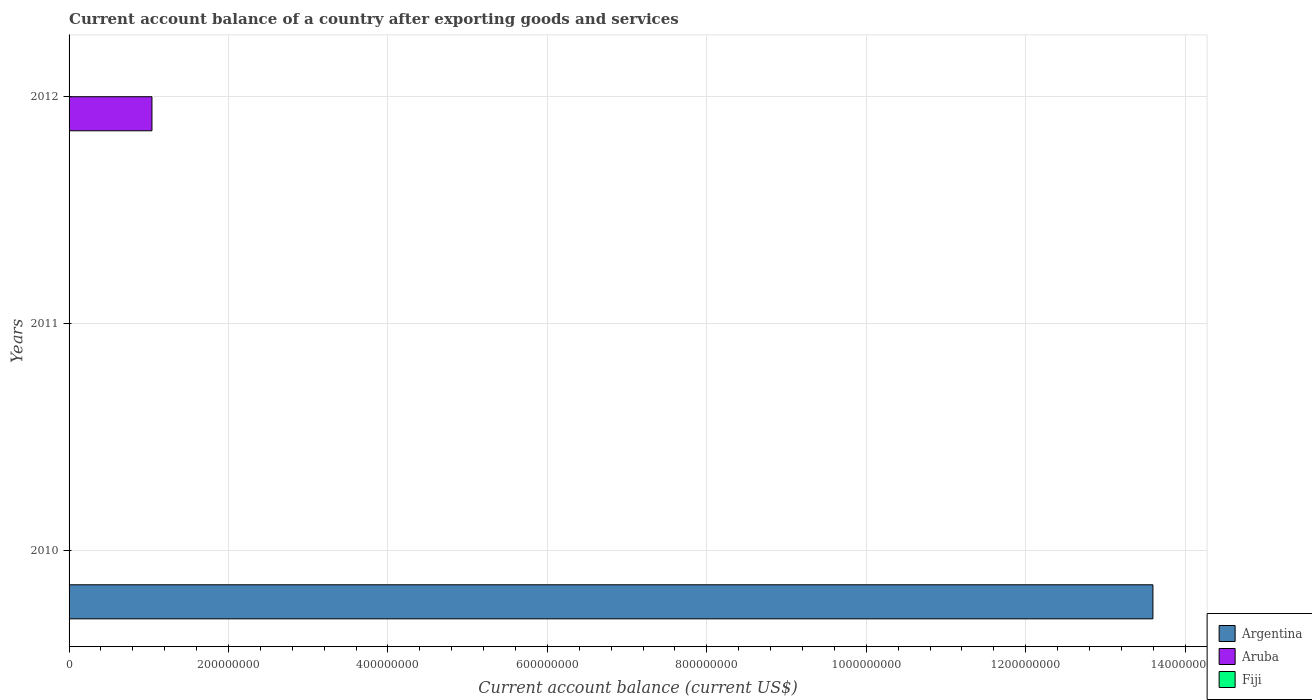How many bars are there on the 3rd tick from the bottom?
Your answer should be compact. 1. In how many cases, is the number of bars for a given year not equal to the number of legend labels?
Make the answer very short. 3. What is the account balance in Argentina in 2012?
Your answer should be very brief. 0. Across all years, what is the maximum account balance in Aruba?
Ensure brevity in your answer.  1.04e+08. Across all years, what is the minimum account balance in Aruba?
Provide a short and direct response. 0. In which year was the account balance in Aruba maximum?
Offer a very short reply. 2012. What is the total account balance in Argentina in the graph?
Provide a succinct answer. 1.36e+09. What is the average account balance in Aruba per year?
Give a very brief answer. 3.47e+07. In how many years, is the account balance in Fiji greater than 1280000000 US$?
Offer a terse response. 0. What is the difference between the highest and the lowest account balance in Argentina?
Ensure brevity in your answer.  1.36e+09. Is it the case that in every year, the sum of the account balance in Argentina and account balance in Fiji is greater than the account balance in Aruba?
Offer a terse response. No. How many years are there in the graph?
Make the answer very short. 3. What is the difference between two consecutive major ticks on the X-axis?
Offer a terse response. 2.00e+08. Does the graph contain any zero values?
Offer a terse response. Yes. Where does the legend appear in the graph?
Ensure brevity in your answer.  Bottom right. How many legend labels are there?
Make the answer very short. 3. What is the title of the graph?
Ensure brevity in your answer.  Current account balance of a country after exporting goods and services. Does "Greenland" appear as one of the legend labels in the graph?
Ensure brevity in your answer.  No. What is the label or title of the X-axis?
Offer a very short reply. Current account balance (current US$). What is the Current account balance (current US$) in Argentina in 2010?
Offer a very short reply. 1.36e+09. What is the Current account balance (current US$) in Fiji in 2010?
Provide a short and direct response. 0. What is the Current account balance (current US$) of Fiji in 2011?
Give a very brief answer. 0. What is the Current account balance (current US$) of Argentina in 2012?
Your answer should be compact. 0. What is the Current account balance (current US$) of Aruba in 2012?
Make the answer very short. 1.04e+08. What is the Current account balance (current US$) in Fiji in 2012?
Your response must be concise. 0. Across all years, what is the maximum Current account balance (current US$) in Argentina?
Your answer should be very brief. 1.36e+09. Across all years, what is the maximum Current account balance (current US$) of Aruba?
Your answer should be compact. 1.04e+08. What is the total Current account balance (current US$) in Argentina in the graph?
Provide a succinct answer. 1.36e+09. What is the total Current account balance (current US$) in Aruba in the graph?
Keep it short and to the point. 1.04e+08. What is the difference between the Current account balance (current US$) of Argentina in 2010 and the Current account balance (current US$) of Aruba in 2012?
Your answer should be very brief. 1.26e+09. What is the average Current account balance (current US$) in Argentina per year?
Offer a terse response. 4.53e+08. What is the average Current account balance (current US$) of Aruba per year?
Your answer should be very brief. 3.47e+07. What is the difference between the highest and the lowest Current account balance (current US$) of Argentina?
Give a very brief answer. 1.36e+09. What is the difference between the highest and the lowest Current account balance (current US$) of Aruba?
Provide a short and direct response. 1.04e+08. 